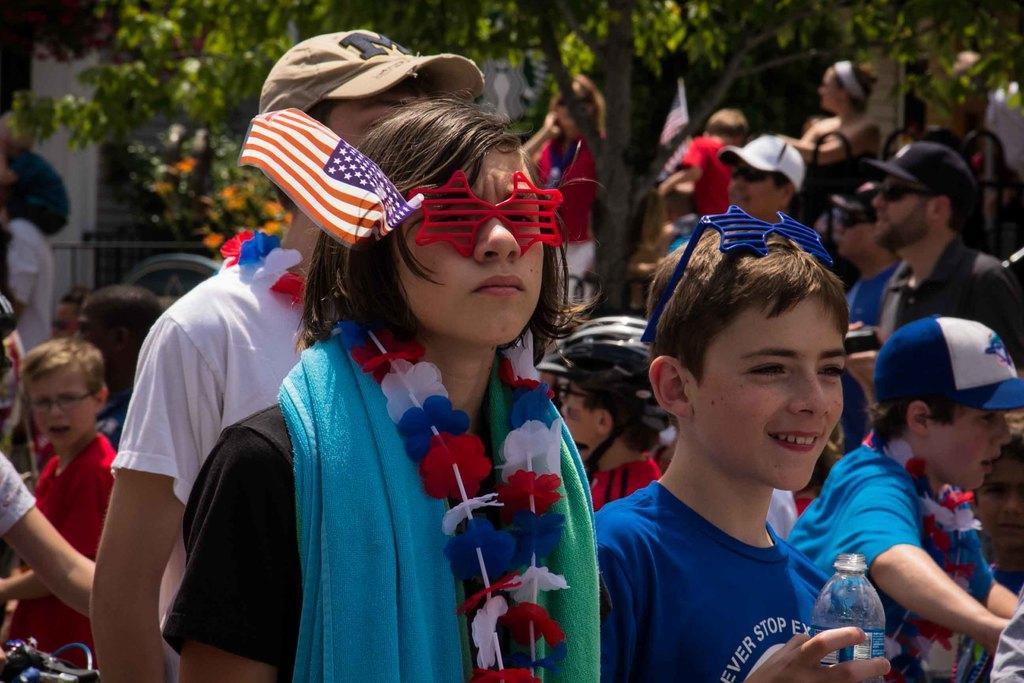How would you summarize this image in a sentence or two? In front of the picture, we see a girl is standing. She is wearing a blue towel and a garland. She is wearing the star shaped eyeglasses and a flag in white, red and blue color. Beside her, we see a boy is standing. He is holding a water bottle in his hands and he is smiling. Behind them, we see the people are standing. Behind them, we see the iron railing. In the left bottom, we see a bicycle. There are trees and a building in the background. This picture is blurred in the background. 